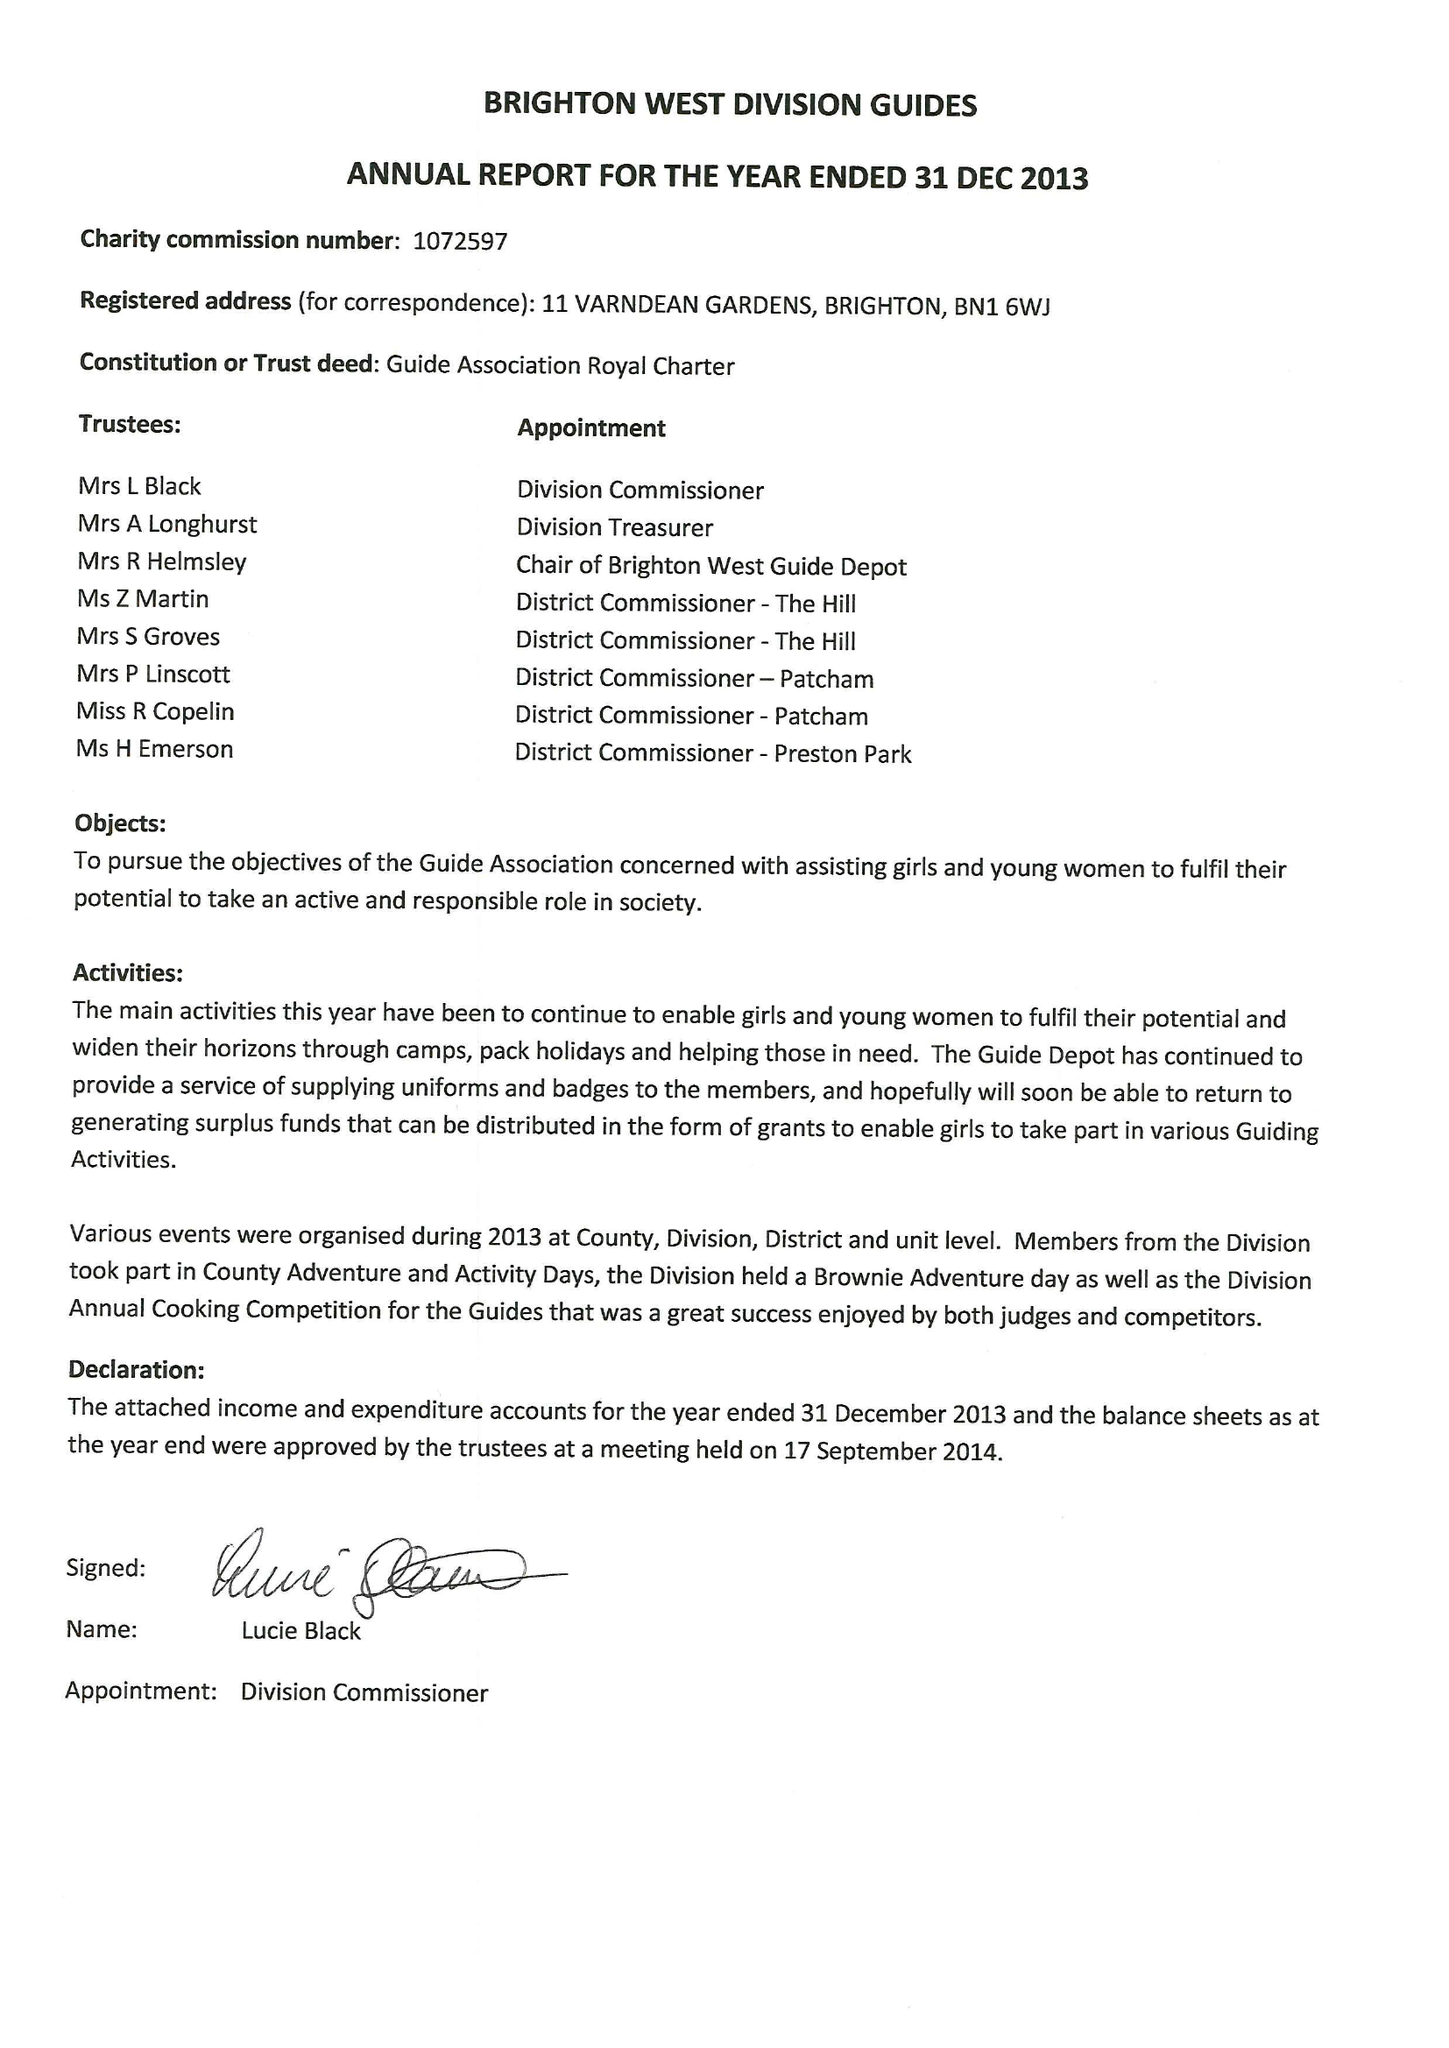What is the value for the address__street_line?
Answer the question using a single word or phrase. 11 VARNDEAN GARDENS 